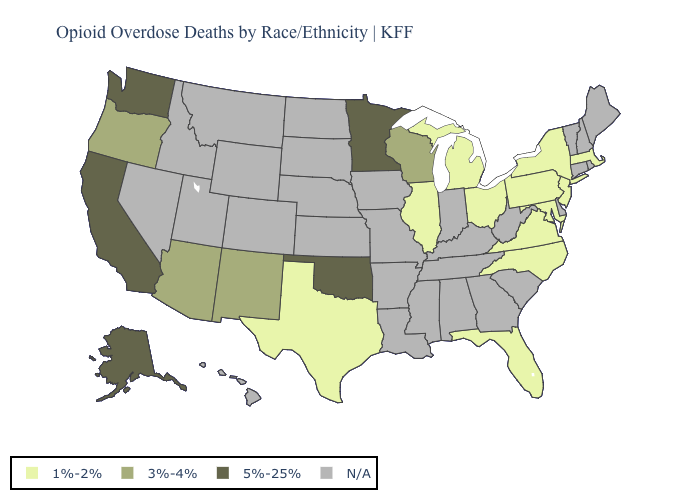Among the states that border Idaho , does Oregon have the highest value?
Quick response, please. No. How many symbols are there in the legend?
Give a very brief answer. 4. Which states have the lowest value in the West?
Write a very short answer. Arizona, New Mexico, Oregon. Which states have the lowest value in the West?
Write a very short answer. Arizona, New Mexico, Oregon. Does the map have missing data?
Answer briefly. Yes. What is the lowest value in the Northeast?
Quick response, please. 1%-2%. What is the lowest value in the USA?
Short answer required. 1%-2%. What is the lowest value in states that border Tennessee?
Write a very short answer. 1%-2%. Name the states that have a value in the range 1%-2%?
Quick response, please. Florida, Illinois, Maryland, Massachusetts, Michigan, New Jersey, New York, North Carolina, Ohio, Pennsylvania, Texas, Virginia. What is the value of Utah?
Quick response, please. N/A. Is the legend a continuous bar?
Give a very brief answer. No. Which states have the lowest value in the South?
Keep it brief. Florida, Maryland, North Carolina, Texas, Virginia. Name the states that have a value in the range N/A?
Answer briefly. Alabama, Arkansas, Colorado, Connecticut, Delaware, Georgia, Hawaii, Idaho, Indiana, Iowa, Kansas, Kentucky, Louisiana, Maine, Mississippi, Missouri, Montana, Nebraska, Nevada, New Hampshire, North Dakota, Rhode Island, South Carolina, South Dakota, Tennessee, Utah, Vermont, West Virginia, Wyoming. What is the value of Montana?
Concise answer only. N/A. 